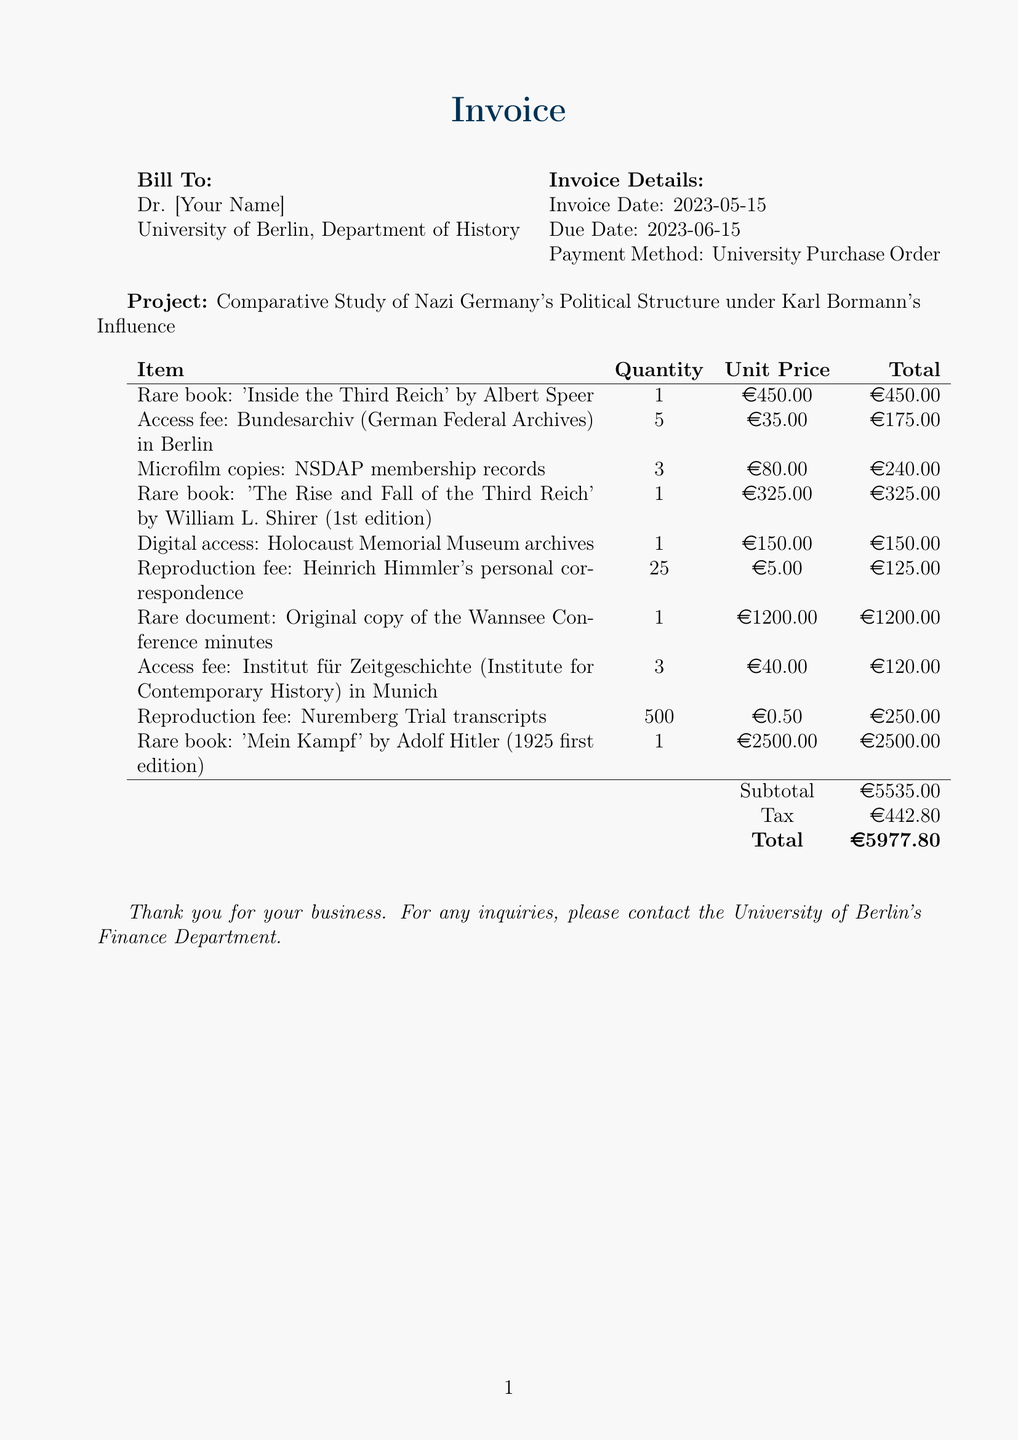what is the invoice date? The invoice date is stated within the document, specifically indicating when the invoice was generated.
Answer: 2023-05-15 who is the bill to? The document specifies the name of the person or entity to whom the invoice is addressed.
Answer: Dr. [Your Name] what is the total amount due? The total amount due is the final sum calculated at the end of the invoice.
Answer: €5977.80 how many access fees are charged for the Bundesarchiv? This question pertains to specific fees for accessing archival materials as stated in the invoice.
Answer: 5 which rare book has the highest price? The document lists various rare books along with their prices, allowing comparison.
Answer: Mein Kampf by Adolf Hitler (1925 first edition) what is the subtotal before tax? The subtotal reflects the sum of all items before any additional costs such as taxes are applied.
Answer: €5535.00 how many reproduction fees were charged for Heinrich Himmler's correspondence? This question is directed at understanding specific charges regarding reproduction materials from the invoice.
Answer: 25 what is the due date for the invoice? The due date indicates when payment for the invoice is expected.
Answer: 2023-06-15 what project is this invoice associated with? This question involves identifying the associated research project noted in the document.
Answer: Comparative Study of Nazi Germany's Political Structure under Karl Bormann's Influence 